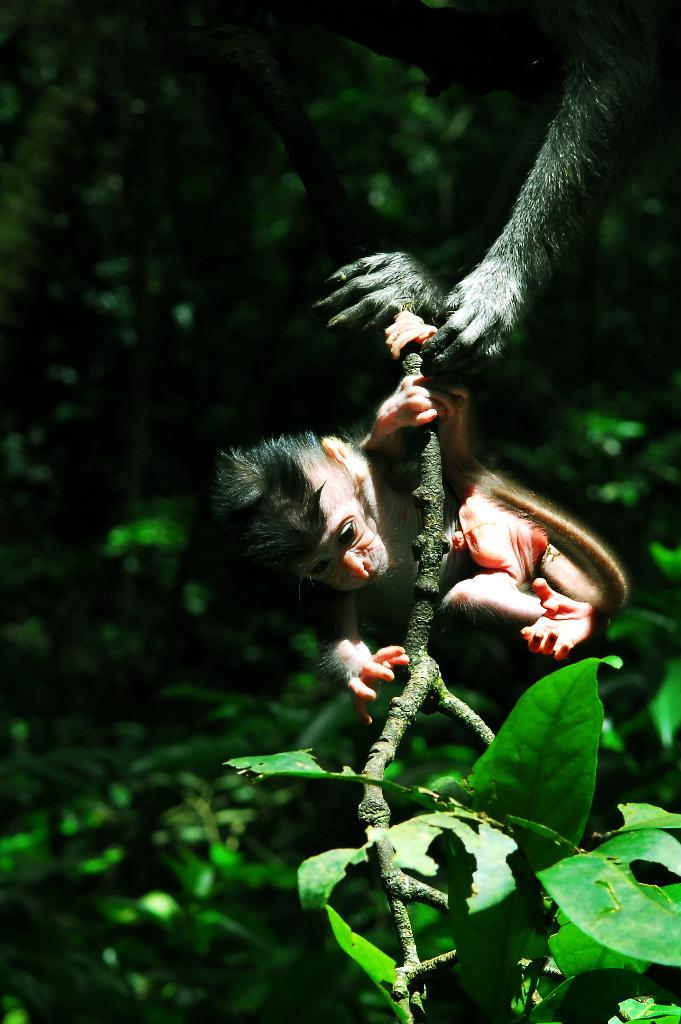Where was the image taken? The image is taken outdoors. What can be seen in the background of the image? There is a tree in the image. What animal is present in the image? There is a monkey in the image. What is the monkey holding in the image? The monkey is holding a branch. What type of gun is the monkey using in the image? There is no gun present in the image; the monkey is holding a branch. What property does the monkey own in the image? There is no mention of property ownership in the image; it simply shows a monkey holding a branch. 